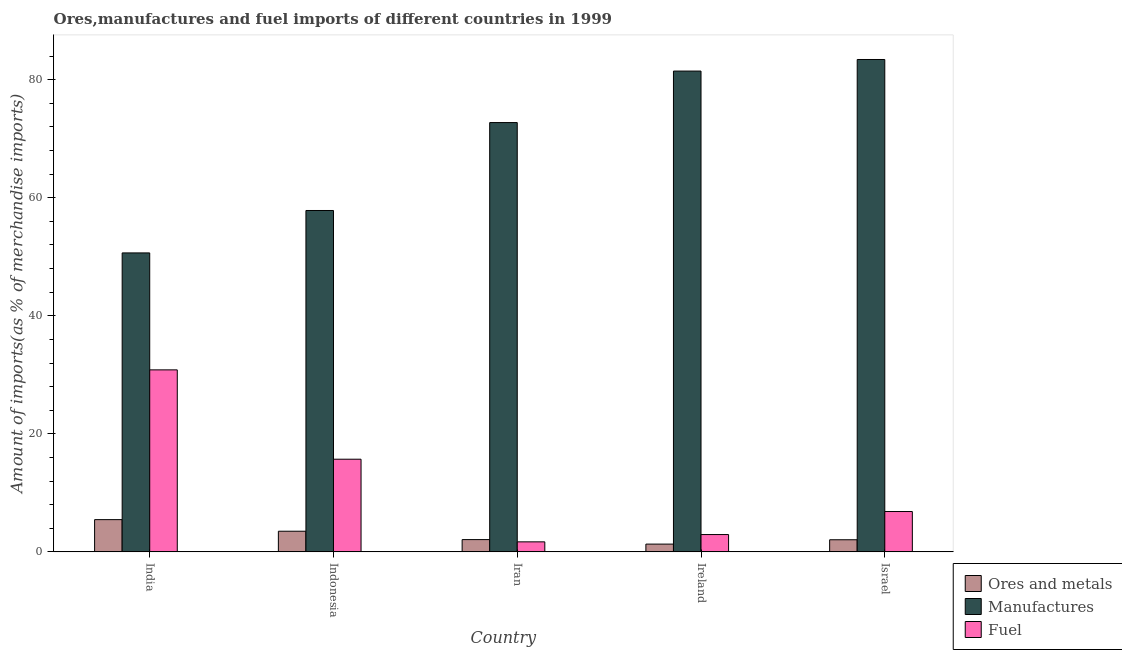How many bars are there on the 5th tick from the left?
Make the answer very short. 3. What is the label of the 4th group of bars from the left?
Offer a very short reply. Ireland. What is the percentage of ores and metals imports in Iran?
Make the answer very short. 2.08. Across all countries, what is the maximum percentage of manufactures imports?
Your response must be concise. 83.43. Across all countries, what is the minimum percentage of manufactures imports?
Give a very brief answer. 50.66. In which country was the percentage of ores and metals imports minimum?
Ensure brevity in your answer.  Ireland. What is the total percentage of ores and metals imports in the graph?
Provide a short and direct response. 14.41. What is the difference between the percentage of ores and metals imports in India and that in Iran?
Make the answer very short. 3.38. What is the difference between the percentage of manufactures imports in Indonesia and the percentage of ores and metals imports in India?
Provide a succinct answer. 52.38. What is the average percentage of manufactures imports per country?
Give a very brief answer. 69.23. What is the difference between the percentage of ores and metals imports and percentage of fuel imports in India?
Your answer should be very brief. -25.38. In how many countries, is the percentage of manufactures imports greater than 44 %?
Keep it short and to the point. 5. What is the ratio of the percentage of fuel imports in Indonesia to that in Israel?
Provide a short and direct response. 2.3. What is the difference between the highest and the second highest percentage of fuel imports?
Make the answer very short. 15.14. What is the difference between the highest and the lowest percentage of fuel imports?
Offer a very short reply. 29.14. Is the sum of the percentage of manufactures imports in India and Indonesia greater than the maximum percentage of fuel imports across all countries?
Give a very brief answer. Yes. What does the 1st bar from the left in Ireland represents?
Offer a terse response. Ores and metals. What does the 3rd bar from the right in Indonesia represents?
Offer a terse response. Ores and metals. How many bars are there?
Provide a short and direct response. 15. Are all the bars in the graph horizontal?
Offer a very short reply. No. What is the difference between two consecutive major ticks on the Y-axis?
Your answer should be compact. 20. Are the values on the major ticks of Y-axis written in scientific E-notation?
Ensure brevity in your answer.  No. Where does the legend appear in the graph?
Keep it short and to the point. Bottom right. What is the title of the graph?
Offer a terse response. Ores,manufactures and fuel imports of different countries in 1999. What is the label or title of the X-axis?
Provide a succinct answer. Country. What is the label or title of the Y-axis?
Give a very brief answer. Amount of imports(as % of merchandise imports). What is the Amount of imports(as % of merchandise imports) of Ores and metals in India?
Make the answer very short. 5.46. What is the Amount of imports(as % of merchandise imports) in Manufactures in India?
Give a very brief answer. 50.66. What is the Amount of imports(as % of merchandise imports) of Fuel in India?
Keep it short and to the point. 30.84. What is the Amount of imports(as % of merchandise imports) in Ores and metals in Indonesia?
Make the answer very short. 3.5. What is the Amount of imports(as % of merchandise imports) of Manufactures in Indonesia?
Your response must be concise. 57.84. What is the Amount of imports(as % of merchandise imports) in Fuel in Indonesia?
Your response must be concise. 15.7. What is the Amount of imports(as % of merchandise imports) in Ores and metals in Iran?
Your response must be concise. 2.08. What is the Amount of imports(as % of merchandise imports) of Manufactures in Iran?
Give a very brief answer. 72.74. What is the Amount of imports(as % of merchandise imports) of Fuel in Iran?
Offer a very short reply. 1.7. What is the Amount of imports(as % of merchandise imports) in Ores and metals in Ireland?
Keep it short and to the point. 1.32. What is the Amount of imports(as % of merchandise imports) in Manufactures in Ireland?
Ensure brevity in your answer.  81.47. What is the Amount of imports(as % of merchandise imports) of Fuel in Ireland?
Ensure brevity in your answer.  2.94. What is the Amount of imports(as % of merchandise imports) in Ores and metals in Israel?
Provide a short and direct response. 2.05. What is the Amount of imports(as % of merchandise imports) of Manufactures in Israel?
Your response must be concise. 83.43. What is the Amount of imports(as % of merchandise imports) of Fuel in Israel?
Provide a short and direct response. 6.84. Across all countries, what is the maximum Amount of imports(as % of merchandise imports) of Ores and metals?
Offer a very short reply. 5.46. Across all countries, what is the maximum Amount of imports(as % of merchandise imports) in Manufactures?
Offer a very short reply. 83.43. Across all countries, what is the maximum Amount of imports(as % of merchandise imports) in Fuel?
Ensure brevity in your answer.  30.84. Across all countries, what is the minimum Amount of imports(as % of merchandise imports) in Ores and metals?
Make the answer very short. 1.32. Across all countries, what is the minimum Amount of imports(as % of merchandise imports) of Manufactures?
Give a very brief answer. 50.66. Across all countries, what is the minimum Amount of imports(as % of merchandise imports) in Fuel?
Give a very brief answer. 1.7. What is the total Amount of imports(as % of merchandise imports) in Ores and metals in the graph?
Offer a very short reply. 14.41. What is the total Amount of imports(as % of merchandise imports) in Manufactures in the graph?
Provide a succinct answer. 346.14. What is the total Amount of imports(as % of merchandise imports) of Fuel in the graph?
Offer a very short reply. 58.01. What is the difference between the Amount of imports(as % of merchandise imports) in Ores and metals in India and that in Indonesia?
Your answer should be compact. 1.96. What is the difference between the Amount of imports(as % of merchandise imports) in Manufactures in India and that in Indonesia?
Provide a succinct answer. -7.19. What is the difference between the Amount of imports(as % of merchandise imports) in Fuel in India and that in Indonesia?
Offer a very short reply. 15.14. What is the difference between the Amount of imports(as % of merchandise imports) of Ores and metals in India and that in Iran?
Offer a very short reply. 3.38. What is the difference between the Amount of imports(as % of merchandise imports) of Manufactures in India and that in Iran?
Ensure brevity in your answer.  -22.09. What is the difference between the Amount of imports(as % of merchandise imports) of Fuel in India and that in Iran?
Provide a short and direct response. 29.14. What is the difference between the Amount of imports(as % of merchandise imports) of Ores and metals in India and that in Ireland?
Keep it short and to the point. 4.15. What is the difference between the Amount of imports(as % of merchandise imports) in Manufactures in India and that in Ireland?
Offer a terse response. -30.81. What is the difference between the Amount of imports(as % of merchandise imports) in Fuel in India and that in Ireland?
Your answer should be very brief. 27.9. What is the difference between the Amount of imports(as % of merchandise imports) of Ores and metals in India and that in Israel?
Your answer should be compact. 3.41. What is the difference between the Amount of imports(as % of merchandise imports) of Manufactures in India and that in Israel?
Give a very brief answer. -32.77. What is the difference between the Amount of imports(as % of merchandise imports) of Fuel in India and that in Israel?
Provide a succinct answer. 24. What is the difference between the Amount of imports(as % of merchandise imports) of Ores and metals in Indonesia and that in Iran?
Provide a short and direct response. 1.42. What is the difference between the Amount of imports(as % of merchandise imports) of Manufactures in Indonesia and that in Iran?
Keep it short and to the point. -14.9. What is the difference between the Amount of imports(as % of merchandise imports) of Fuel in Indonesia and that in Iran?
Give a very brief answer. 14. What is the difference between the Amount of imports(as % of merchandise imports) of Ores and metals in Indonesia and that in Ireland?
Make the answer very short. 2.18. What is the difference between the Amount of imports(as % of merchandise imports) of Manufactures in Indonesia and that in Ireland?
Keep it short and to the point. -23.62. What is the difference between the Amount of imports(as % of merchandise imports) in Fuel in Indonesia and that in Ireland?
Provide a succinct answer. 12.76. What is the difference between the Amount of imports(as % of merchandise imports) of Ores and metals in Indonesia and that in Israel?
Offer a terse response. 1.45. What is the difference between the Amount of imports(as % of merchandise imports) of Manufactures in Indonesia and that in Israel?
Your answer should be compact. -25.59. What is the difference between the Amount of imports(as % of merchandise imports) of Fuel in Indonesia and that in Israel?
Provide a short and direct response. 8.86. What is the difference between the Amount of imports(as % of merchandise imports) in Ores and metals in Iran and that in Ireland?
Offer a very short reply. 0.76. What is the difference between the Amount of imports(as % of merchandise imports) in Manufactures in Iran and that in Ireland?
Provide a succinct answer. -8.73. What is the difference between the Amount of imports(as % of merchandise imports) in Fuel in Iran and that in Ireland?
Offer a terse response. -1.24. What is the difference between the Amount of imports(as % of merchandise imports) in Ores and metals in Iran and that in Israel?
Offer a terse response. 0.03. What is the difference between the Amount of imports(as % of merchandise imports) in Manufactures in Iran and that in Israel?
Provide a short and direct response. -10.69. What is the difference between the Amount of imports(as % of merchandise imports) of Fuel in Iran and that in Israel?
Your answer should be compact. -5.14. What is the difference between the Amount of imports(as % of merchandise imports) in Ores and metals in Ireland and that in Israel?
Your response must be concise. -0.74. What is the difference between the Amount of imports(as % of merchandise imports) of Manufactures in Ireland and that in Israel?
Your response must be concise. -1.96. What is the difference between the Amount of imports(as % of merchandise imports) of Ores and metals in India and the Amount of imports(as % of merchandise imports) of Manufactures in Indonesia?
Make the answer very short. -52.38. What is the difference between the Amount of imports(as % of merchandise imports) in Ores and metals in India and the Amount of imports(as % of merchandise imports) in Fuel in Indonesia?
Make the answer very short. -10.24. What is the difference between the Amount of imports(as % of merchandise imports) of Manufactures in India and the Amount of imports(as % of merchandise imports) of Fuel in Indonesia?
Keep it short and to the point. 34.96. What is the difference between the Amount of imports(as % of merchandise imports) of Ores and metals in India and the Amount of imports(as % of merchandise imports) of Manufactures in Iran?
Offer a very short reply. -67.28. What is the difference between the Amount of imports(as % of merchandise imports) in Ores and metals in India and the Amount of imports(as % of merchandise imports) in Fuel in Iran?
Provide a short and direct response. 3.77. What is the difference between the Amount of imports(as % of merchandise imports) of Manufactures in India and the Amount of imports(as % of merchandise imports) of Fuel in Iran?
Your answer should be compact. 48.96. What is the difference between the Amount of imports(as % of merchandise imports) of Ores and metals in India and the Amount of imports(as % of merchandise imports) of Manufactures in Ireland?
Make the answer very short. -76.01. What is the difference between the Amount of imports(as % of merchandise imports) of Ores and metals in India and the Amount of imports(as % of merchandise imports) of Fuel in Ireland?
Give a very brief answer. 2.53. What is the difference between the Amount of imports(as % of merchandise imports) of Manufactures in India and the Amount of imports(as % of merchandise imports) of Fuel in Ireland?
Make the answer very short. 47.72. What is the difference between the Amount of imports(as % of merchandise imports) in Ores and metals in India and the Amount of imports(as % of merchandise imports) in Manufactures in Israel?
Your response must be concise. -77.97. What is the difference between the Amount of imports(as % of merchandise imports) in Ores and metals in India and the Amount of imports(as % of merchandise imports) in Fuel in Israel?
Ensure brevity in your answer.  -1.37. What is the difference between the Amount of imports(as % of merchandise imports) in Manufactures in India and the Amount of imports(as % of merchandise imports) in Fuel in Israel?
Keep it short and to the point. 43.82. What is the difference between the Amount of imports(as % of merchandise imports) of Ores and metals in Indonesia and the Amount of imports(as % of merchandise imports) of Manufactures in Iran?
Provide a short and direct response. -69.24. What is the difference between the Amount of imports(as % of merchandise imports) in Ores and metals in Indonesia and the Amount of imports(as % of merchandise imports) in Fuel in Iran?
Your response must be concise. 1.8. What is the difference between the Amount of imports(as % of merchandise imports) in Manufactures in Indonesia and the Amount of imports(as % of merchandise imports) in Fuel in Iran?
Your answer should be compact. 56.15. What is the difference between the Amount of imports(as % of merchandise imports) in Ores and metals in Indonesia and the Amount of imports(as % of merchandise imports) in Manufactures in Ireland?
Offer a terse response. -77.97. What is the difference between the Amount of imports(as % of merchandise imports) of Ores and metals in Indonesia and the Amount of imports(as % of merchandise imports) of Fuel in Ireland?
Ensure brevity in your answer.  0.56. What is the difference between the Amount of imports(as % of merchandise imports) of Manufactures in Indonesia and the Amount of imports(as % of merchandise imports) of Fuel in Ireland?
Keep it short and to the point. 54.91. What is the difference between the Amount of imports(as % of merchandise imports) in Ores and metals in Indonesia and the Amount of imports(as % of merchandise imports) in Manufactures in Israel?
Offer a terse response. -79.93. What is the difference between the Amount of imports(as % of merchandise imports) of Ores and metals in Indonesia and the Amount of imports(as % of merchandise imports) of Fuel in Israel?
Ensure brevity in your answer.  -3.34. What is the difference between the Amount of imports(as % of merchandise imports) of Manufactures in Indonesia and the Amount of imports(as % of merchandise imports) of Fuel in Israel?
Your answer should be compact. 51.01. What is the difference between the Amount of imports(as % of merchandise imports) of Ores and metals in Iran and the Amount of imports(as % of merchandise imports) of Manufactures in Ireland?
Your response must be concise. -79.39. What is the difference between the Amount of imports(as % of merchandise imports) of Ores and metals in Iran and the Amount of imports(as % of merchandise imports) of Fuel in Ireland?
Your answer should be very brief. -0.86. What is the difference between the Amount of imports(as % of merchandise imports) in Manufactures in Iran and the Amount of imports(as % of merchandise imports) in Fuel in Ireland?
Your answer should be compact. 69.81. What is the difference between the Amount of imports(as % of merchandise imports) in Ores and metals in Iran and the Amount of imports(as % of merchandise imports) in Manufactures in Israel?
Provide a succinct answer. -81.35. What is the difference between the Amount of imports(as % of merchandise imports) of Ores and metals in Iran and the Amount of imports(as % of merchandise imports) of Fuel in Israel?
Ensure brevity in your answer.  -4.76. What is the difference between the Amount of imports(as % of merchandise imports) of Manufactures in Iran and the Amount of imports(as % of merchandise imports) of Fuel in Israel?
Your answer should be compact. 65.91. What is the difference between the Amount of imports(as % of merchandise imports) of Ores and metals in Ireland and the Amount of imports(as % of merchandise imports) of Manufactures in Israel?
Your answer should be very brief. -82.11. What is the difference between the Amount of imports(as % of merchandise imports) of Ores and metals in Ireland and the Amount of imports(as % of merchandise imports) of Fuel in Israel?
Make the answer very short. -5.52. What is the difference between the Amount of imports(as % of merchandise imports) in Manufactures in Ireland and the Amount of imports(as % of merchandise imports) in Fuel in Israel?
Your response must be concise. 74.63. What is the average Amount of imports(as % of merchandise imports) in Ores and metals per country?
Ensure brevity in your answer.  2.88. What is the average Amount of imports(as % of merchandise imports) of Manufactures per country?
Give a very brief answer. 69.23. What is the average Amount of imports(as % of merchandise imports) of Fuel per country?
Your response must be concise. 11.6. What is the difference between the Amount of imports(as % of merchandise imports) of Ores and metals and Amount of imports(as % of merchandise imports) of Manufactures in India?
Your answer should be very brief. -45.19. What is the difference between the Amount of imports(as % of merchandise imports) in Ores and metals and Amount of imports(as % of merchandise imports) in Fuel in India?
Make the answer very short. -25.38. What is the difference between the Amount of imports(as % of merchandise imports) in Manufactures and Amount of imports(as % of merchandise imports) in Fuel in India?
Your answer should be very brief. 19.82. What is the difference between the Amount of imports(as % of merchandise imports) in Ores and metals and Amount of imports(as % of merchandise imports) in Manufactures in Indonesia?
Your answer should be very brief. -54.34. What is the difference between the Amount of imports(as % of merchandise imports) of Ores and metals and Amount of imports(as % of merchandise imports) of Fuel in Indonesia?
Offer a very short reply. -12.2. What is the difference between the Amount of imports(as % of merchandise imports) of Manufactures and Amount of imports(as % of merchandise imports) of Fuel in Indonesia?
Make the answer very short. 42.14. What is the difference between the Amount of imports(as % of merchandise imports) in Ores and metals and Amount of imports(as % of merchandise imports) in Manufactures in Iran?
Keep it short and to the point. -70.66. What is the difference between the Amount of imports(as % of merchandise imports) of Ores and metals and Amount of imports(as % of merchandise imports) of Fuel in Iran?
Your answer should be compact. 0.38. What is the difference between the Amount of imports(as % of merchandise imports) in Manufactures and Amount of imports(as % of merchandise imports) in Fuel in Iran?
Ensure brevity in your answer.  71.04. What is the difference between the Amount of imports(as % of merchandise imports) in Ores and metals and Amount of imports(as % of merchandise imports) in Manufactures in Ireland?
Keep it short and to the point. -80.15. What is the difference between the Amount of imports(as % of merchandise imports) of Ores and metals and Amount of imports(as % of merchandise imports) of Fuel in Ireland?
Provide a succinct answer. -1.62. What is the difference between the Amount of imports(as % of merchandise imports) of Manufactures and Amount of imports(as % of merchandise imports) of Fuel in Ireland?
Offer a very short reply. 78.53. What is the difference between the Amount of imports(as % of merchandise imports) of Ores and metals and Amount of imports(as % of merchandise imports) of Manufactures in Israel?
Make the answer very short. -81.38. What is the difference between the Amount of imports(as % of merchandise imports) in Ores and metals and Amount of imports(as % of merchandise imports) in Fuel in Israel?
Keep it short and to the point. -4.78. What is the difference between the Amount of imports(as % of merchandise imports) in Manufactures and Amount of imports(as % of merchandise imports) in Fuel in Israel?
Offer a very short reply. 76.59. What is the ratio of the Amount of imports(as % of merchandise imports) of Ores and metals in India to that in Indonesia?
Give a very brief answer. 1.56. What is the ratio of the Amount of imports(as % of merchandise imports) of Manufactures in India to that in Indonesia?
Your response must be concise. 0.88. What is the ratio of the Amount of imports(as % of merchandise imports) of Fuel in India to that in Indonesia?
Your response must be concise. 1.96. What is the ratio of the Amount of imports(as % of merchandise imports) of Ores and metals in India to that in Iran?
Your response must be concise. 2.63. What is the ratio of the Amount of imports(as % of merchandise imports) of Manufactures in India to that in Iran?
Provide a succinct answer. 0.7. What is the ratio of the Amount of imports(as % of merchandise imports) of Fuel in India to that in Iran?
Give a very brief answer. 18.17. What is the ratio of the Amount of imports(as % of merchandise imports) of Ores and metals in India to that in Ireland?
Your answer should be compact. 4.15. What is the ratio of the Amount of imports(as % of merchandise imports) in Manufactures in India to that in Ireland?
Keep it short and to the point. 0.62. What is the ratio of the Amount of imports(as % of merchandise imports) in Fuel in India to that in Ireland?
Your response must be concise. 10.5. What is the ratio of the Amount of imports(as % of merchandise imports) in Ores and metals in India to that in Israel?
Keep it short and to the point. 2.66. What is the ratio of the Amount of imports(as % of merchandise imports) of Manufactures in India to that in Israel?
Your response must be concise. 0.61. What is the ratio of the Amount of imports(as % of merchandise imports) of Fuel in India to that in Israel?
Your answer should be very brief. 4.51. What is the ratio of the Amount of imports(as % of merchandise imports) of Ores and metals in Indonesia to that in Iran?
Make the answer very short. 1.68. What is the ratio of the Amount of imports(as % of merchandise imports) of Manufactures in Indonesia to that in Iran?
Your response must be concise. 0.8. What is the ratio of the Amount of imports(as % of merchandise imports) in Fuel in Indonesia to that in Iran?
Offer a terse response. 9.25. What is the ratio of the Amount of imports(as % of merchandise imports) in Ores and metals in Indonesia to that in Ireland?
Provide a succinct answer. 2.66. What is the ratio of the Amount of imports(as % of merchandise imports) of Manufactures in Indonesia to that in Ireland?
Keep it short and to the point. 0.71. What is the ratio of the Amount of imports(as % of merchandise imports) in Fuel in Indonesia to that in Ireland?
Provide a succinct answer. 5.35. What is the ratio of the Amount of imports(as % of merchandise imports) of Ores and metals in Indonesia to that in Israel?
Give a very brief answer. 1.7. What is the ratio of the Amount of imports(as % of merchandise imports) of Manufactures in Indonesia to that in Israel?
Offer a terse response. 0.69. What is the ratio of the Amount of imports(as % of merchandise imports) in Fuel in Indonesia to that in Israel?
Keep it short and to the point. 2.3. What is the ratio of the Amount of imports(as % of merchandise imports) of Ores and metals in Iran to that in Ireland?
Your answer should be compact. 1.58. What is the ratio of the Amount of imports(as % of merchandise imports) of Manufactures in Iran to that in Ireland?
Make the answer very short. 0.89. What is the ratio of the Amount of imports(as % of merchandise imports) of Fuel in Iran to that in Ireland?
Your answer should be very brief. 0.58. What is the ratio of the Amount of imports(as % of merchandise imports) of Ores and metals in Iran to that in Israel?
Give a very brief answer. 1.01. What is the ratio of the Amount of imports(as % of merchandise imports) of Manufactures in Iran to that in Israel?
Keep it short and to the point. 0.87. What is the ratio of the Amount of imports(as % of merchandise imports) in Fuel in Iran to that in Israel?
Give a very brief answer. 0.25. What is the ratio of the Amount of imports(as % of merchandise imports) in Ores and metals in Ireland to that in Israel?
Provide a succinct answer. 0.64. What is the ratio of the Amount of imports(as % of merchandise imports) of Manufactures in Ireland to that in Israel?
Offer a terse response. 0.98. What is the ratio of the Amount of imports(as % of merchandise imports) of Fuel in Ireland to that in Israel?
Offer a very short reply. 0.43. What is the difference between the highest and the second highest Amount of imports(as % of merchandise imports) in Ores and metals?
Your response must be concise. 1.96. What is the difference between the highest and the second highest Amount of imports(as % of merchandise imports) in Manufactures?
Provide a succinct answer. 1.96. What is the difference between the highest and the second highest Amount of imports(as % of merchandise imports) in Fuel?
Your answer should be very brief. 15.14. What is the difference between the highest and the lowest Amount of imports(as % of merchandise imports) in Ores and metals?
Keep it short and to the point. 4.15. What is the difference between the highest and the lowest Amount of imports(as % of merchandise imports) in Manufactures?
Provide a succinct answer. 32.77. What is the difference between the highest and the lowest Amount of imports(as % of merchandise imports) of Fuel?
Your answer should be compact. 29.14. 